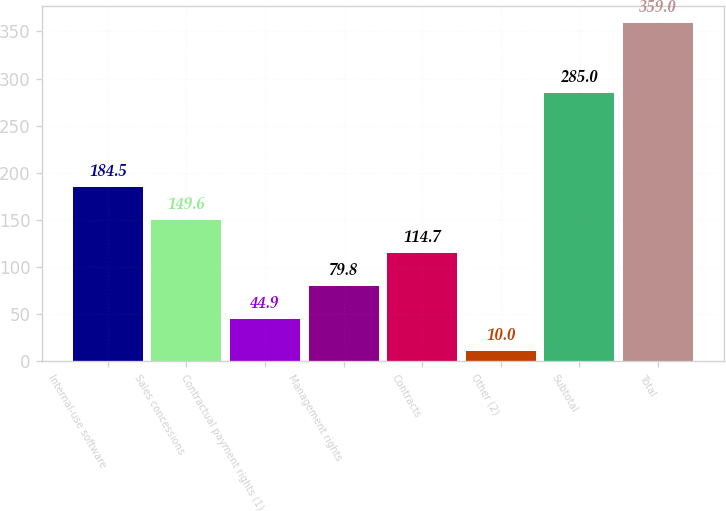Convert chart to OTSL. <chart><loc_0><loc_0><loc_500><loc_500><bar_chart><fcel>Internal-use software<fcel>Sales concessions<fcel>Contractual payment rights (1)<fcel>Management rights<fcel>Contracts<fcel>Other (2)<fcel>Subtotal<fcel>Total<nl><fcel>184.5<fcel>149.6<fcel>44.9<fcel>79.8<fcel>114.7<fcel>10<fcel>285<fcel>359<nl></chart> 